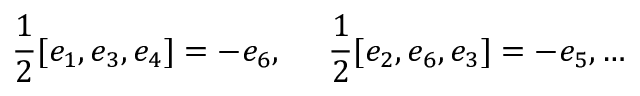Convert formula to latex. <formula><loc_0><loc_0><loc_500><loc_500>\frac { 1 } { 2 } [ e _ { 1 } , e _ { 3 } , e _ { 4 } ] = - e _ { 6 } , \frac { 1 } { 2 } [ e _ { 2 } , e _ { 6 } , e _ { 3 } ] = - e _ { 5 } , \dots</formula> 